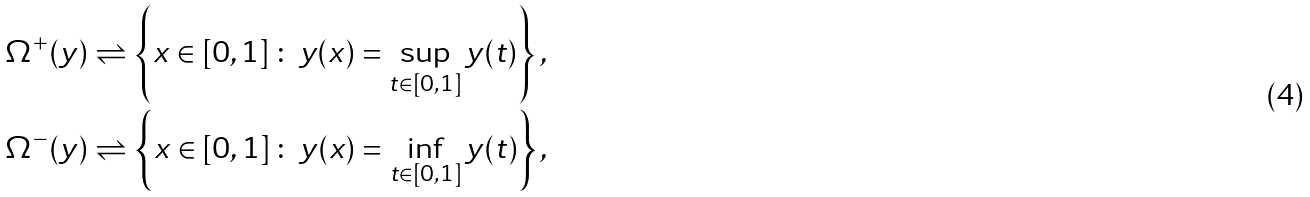<formula> <loc_0><loc_0><loc_500><loc_500>\Omega ^ { + } ( y ) & \rightleftharpoons \left \{ x \in [ 0 , 1 ] \, \colon \, y ( x ) = \sup _ { t \in [ 0 , 1 ] } y ( t ) \right \} , \\ \Omega ^ { - } ( y ) & \rightleftharpoons \left \{ x \in [ 0 , 1 ] \, \colon \, y ( x ) = \inf _ { t \in [ 0 , 1 ] } y ( t ) \right \} ,</formula> 